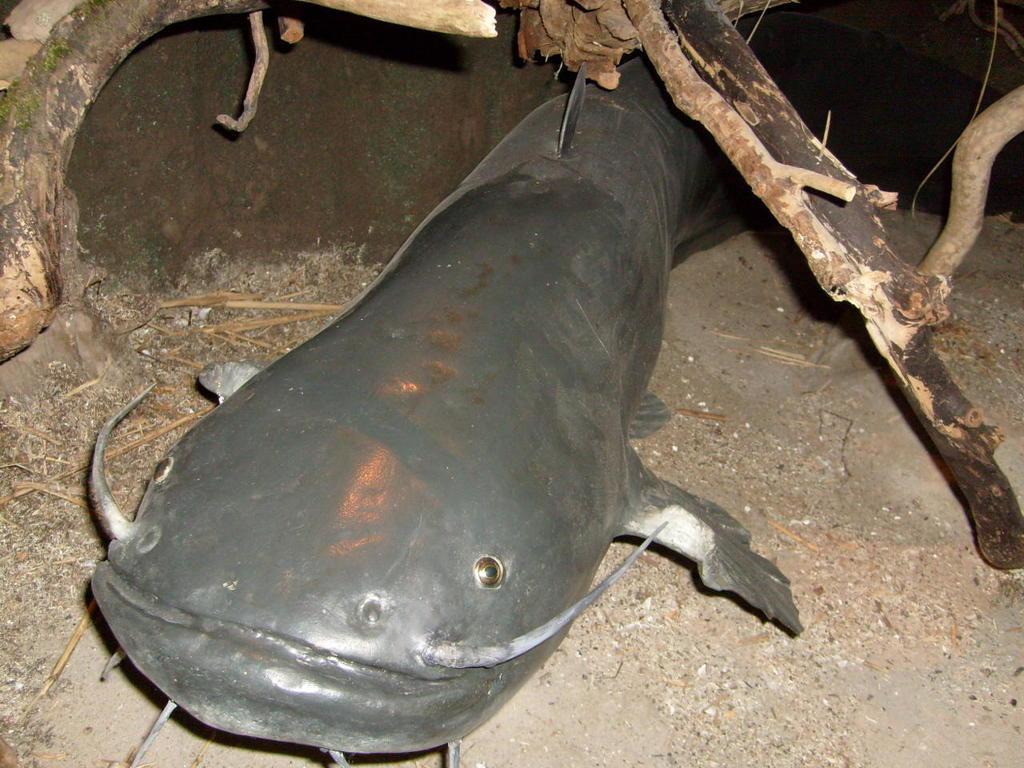Describe this image in one or two sentences. In this image, I can see a catfish on the ground. On the left and right side of the image, I can see the branches. 